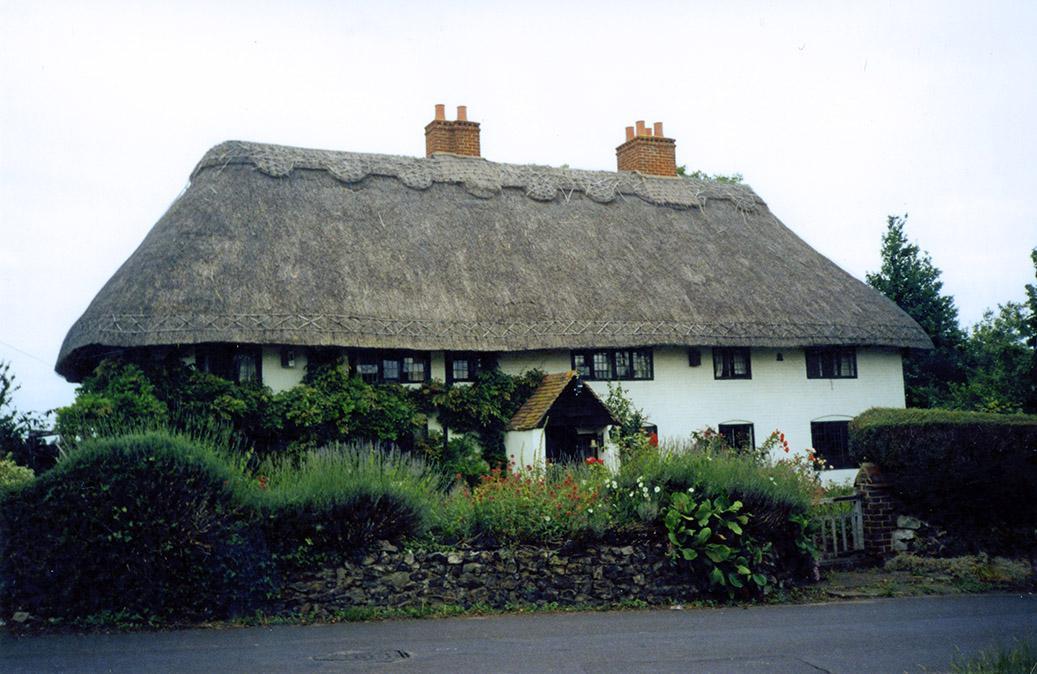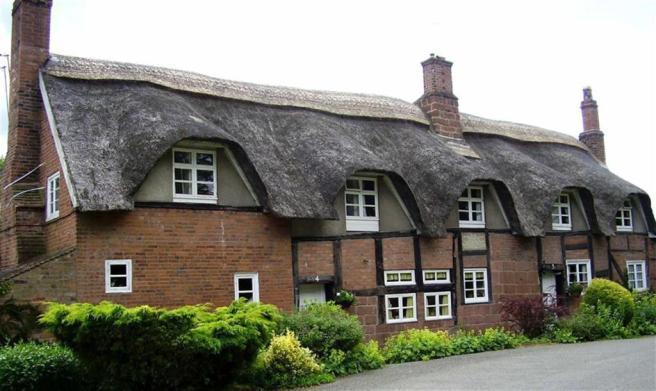The first image is the image on the left, the second image is the image on the right. Given the left and right images, does the statement "A fence is put up around the house on the right." hold true? Answer yes or no. No. The first image is the image on the left, the second image is the image on the right. Given the left and right images, does the statement "There are fewer than five chimneys." hold true? Answer yes or no. No. 